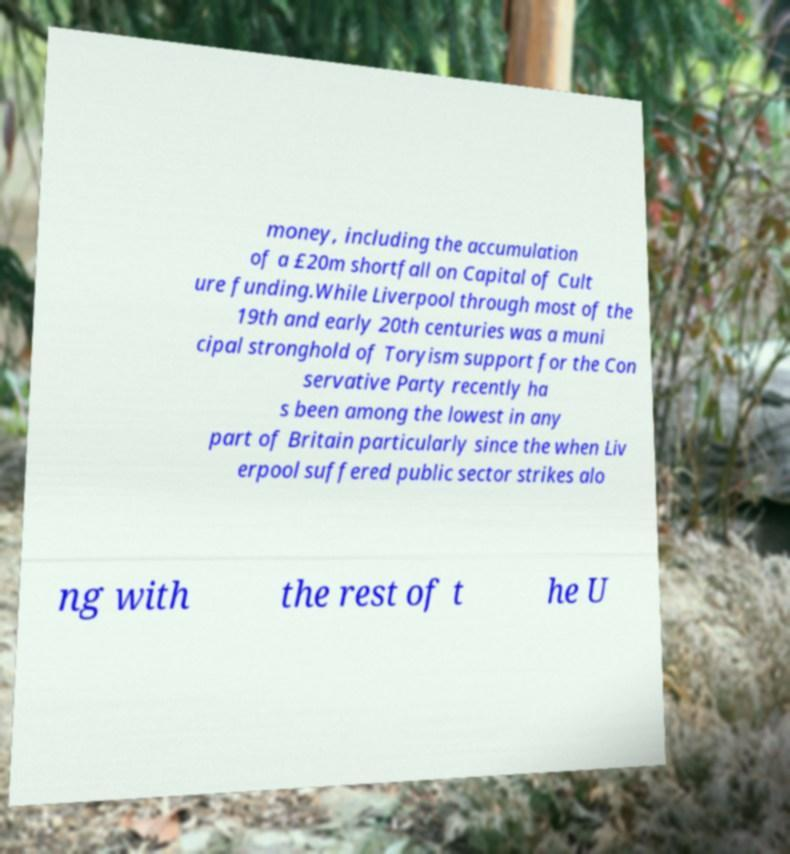For documentation purposes, I need the text within this image transcribed. Could you provide that? money, including the accumulation of a £20m shortfall on Capital of Cult ure funding.While Liverpool through most of the 19th and early 20th centuries was a muni cipal stronghold of Toryism support for the Con servative Party recently ha s been among the lowest in any part of Britain particularly since the when Liv erpool suffered public sector strikes alo ng with the rest of t he U 